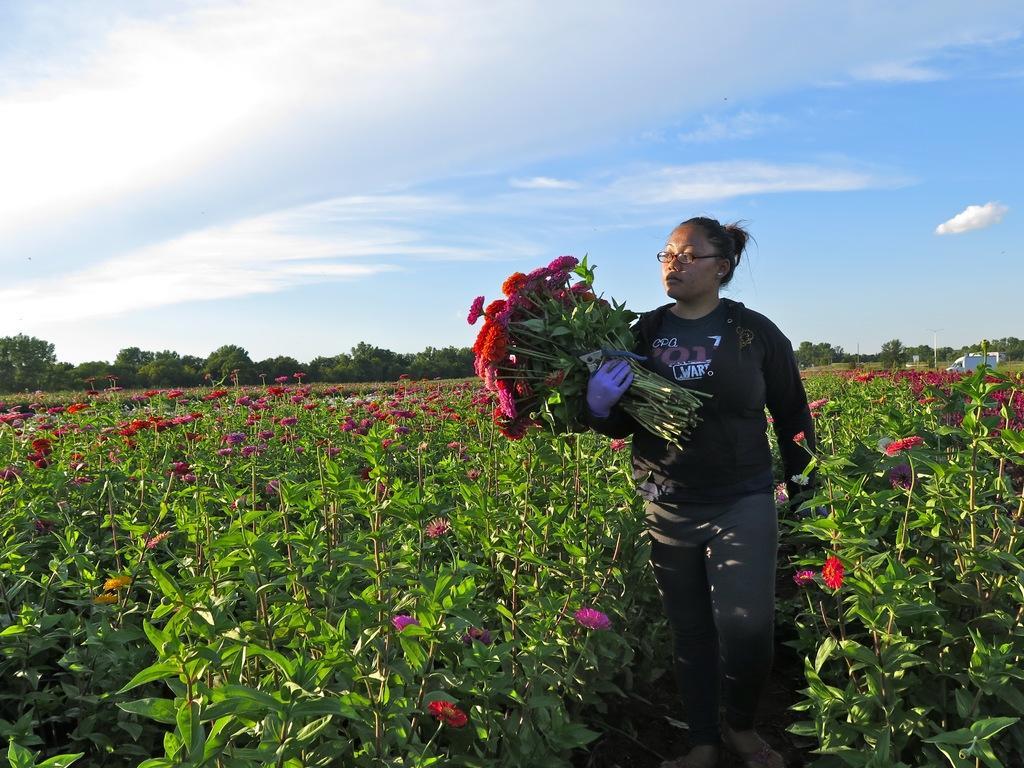Could you give a brief overview of what you see in this image? In this image I can see a woman is holding flowers in her hand. In the background I can see a flower garden, trees and a house. On the top I can see the sky. This image is taken in farm during a day. 